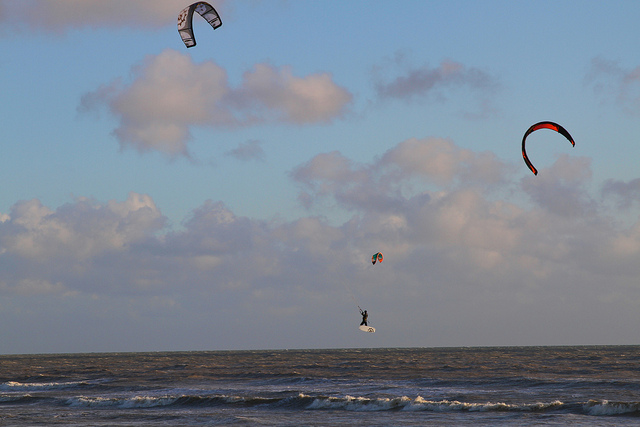What time of day does the image suggest, and how can you tell? The image, bathed in a warm, golden hue, hints at a time around late afternoon or early evening. This supposition is supported by the long shadows cast on the water and the relatively low position of the kites against the sky, suggesting the sun is not at its zenith but rather heading towards the horizon. What kind of weather conditions are ideal for kite surfing? Kite surfing thrives under a clear set of weather conditions: steady winds ranging from 12 to 35 knots, which provide enough force to lift and propel the surfer without becoming unruly or dangerous, and a clear sky, such as the one in this image, which suggests the absence of stormy weather that could introduce hazardous turbulence. 